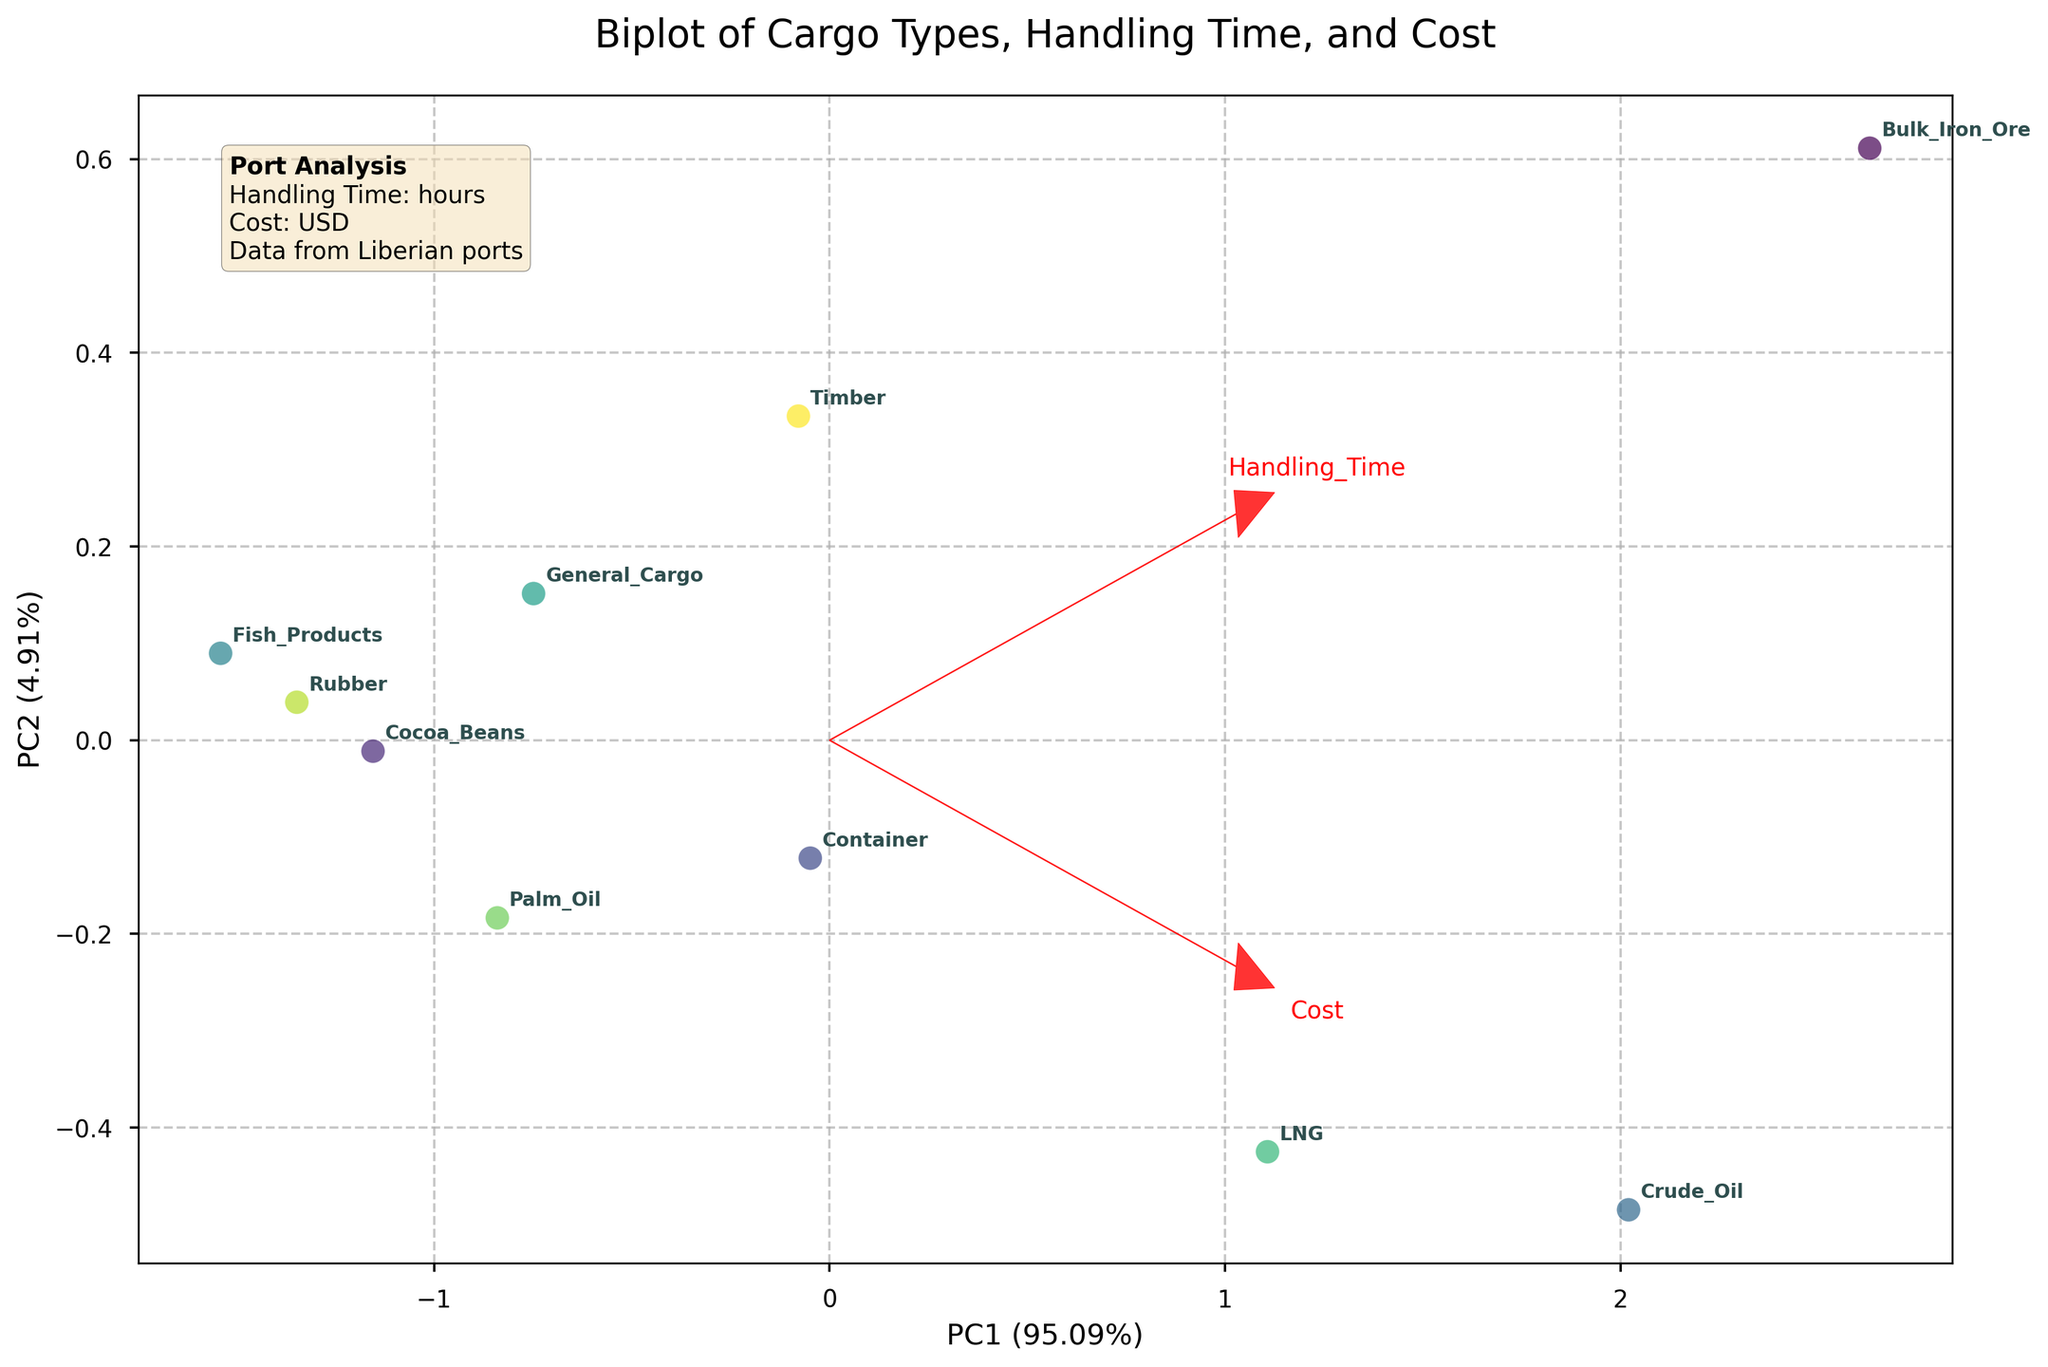What does the title of the figure say? The title is displayed prominently at the top of the figure. It reads "Biplot of Cargo Types, Handling Time, and Cost"
Answer: Biplot of Cargo Types, Handling Time, and Cost Which cargo type appears to have the highest cost based on the biplot? The biplot shows data points scattered and labeled with cargo types. The cargo type with the highest cost is positioned furthest along the axis corresponding to cost.
Answer: Crude_Oil How many cargo types are represented in the biplot? Count the distinct points or labels in the scatter plot, as each point represents a different cargo type.
Answer: 10 Which port has the cargo type with the shortest handling time? Observing the scatter plot, each cargo type is associated with a handling time. Find the name of the cargo type with the lowest handling time and look up its corresponding port in the provided data.
Answer: Port_of_Harper Are there more ports handling bulk cargo or container cargo according to the figure? The biplot shows data points labeled by cargo type. Identify and count the cargo types related to bulk and container categories.
Answer: More ports handle bulk cargo Which two cargo types have the closest handling times? By inspecting the scatter plot, identify the points that are situated close to each other along the axis representing handling time.
Answer: Cocoa_Beans and Fish_Products What can be inferred about the relationship between handling time and cost from the biplot? The biplot shows the direction and magnitude of the loadings arrows for handling time and cost. Analyze their relative positions and directions to make inferences about the correlation.
Answer: They appear positively correlated Which cargo type has the lowest handling time and cost combination? Locate the point that is closest to the origin (0,0) in the scatter plot which represents low handling time and low cost.
Answer: Fish_Products What does the red arrow labeled 'Cost' indicate in the biplot? The red arrow labeled 'Cost' indicates the direction and magnitude of the variable 'Cost' in the principal component space. It shows how this variable influences the spread of data along the principal components.
Answer: Direction and influence of 'Cost' 